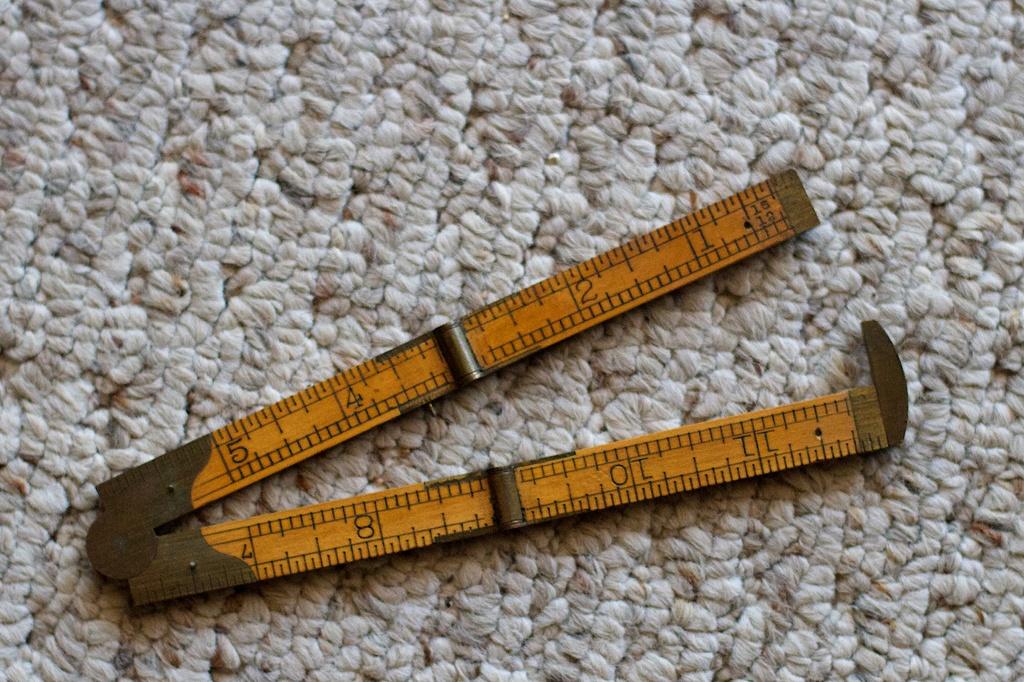How many inches is the ruler?
Provide a short and direct response. 12. What it the first unit of measure?
Keep it short and to the point. Unanswerable. 